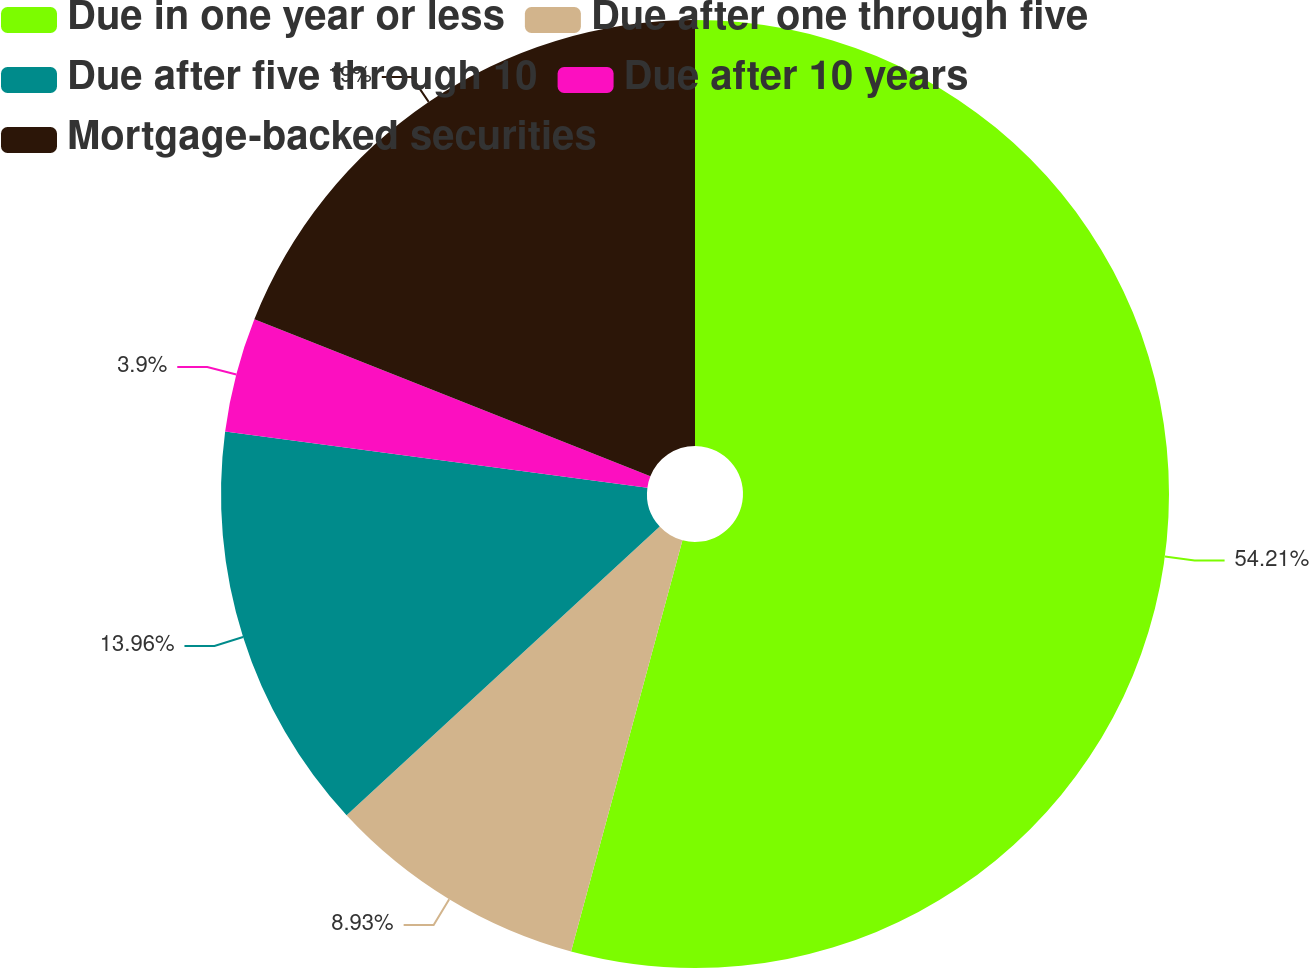<chart> <loc_0><loc_0><loc_500><loc_500><pie_chart><fcel>Due in one year or less<fcel>Due after one through five<fcel>Due after five through 10<fcel>Due after 10 years<fcel>Mortgage-backed securities<nl><fcel>54.2%<fcel>8.93%<fcel>13.96%<fcel>3.9%<fcel>18.99%<nl></chart> 